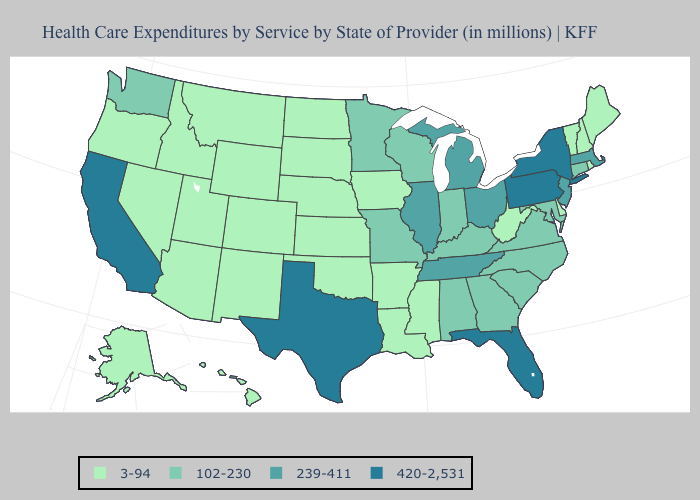Does the first symbol in the legend represent the smallest category?
Short answer required. Yes. Name the states that have a value in the range 239-411?
Keep it brief. Illinois, Massachusetts, Michigan, New Jersey, Ohio, Tennessee. Name the states that have a value in the range 420-2,531?
Quick response, please. California, Florida, New York, Pennsylvania, Texas. Which states have the lowest value in the USA?
Concise answer only. Alaska, Arizona, Arkansas, Colorado, Delaware, Hawaii, Idaho, Iowa, Kansas, Louisiana, Maine, Mississippi, Montana, Nebraska, Nevada, New Hampshire, New Mexico, North Dakota, Oklahoma, Oregon, Rhode Island, South Dakota, Utah, Vermont, West Virginia, Wyoming. Does Wyoming have the highest value in the USA?
Short answer required. No. Does Minnesota have the highest value in the USA?
Write a very short answer. No. Is the legend a continuous bar?
Quick response, please. No. Name the states that have a value in the range 102-230?
Write a very short answer. Alabama, Connecticut, Georgia, Indiana, Kentucky, Maryland, Minnesota, Missouri, North Carolina, South Carolina, Virginia, Washington, Wisconsin. What is the value of Nebraska?
Quick response, please. 3-94. Does North Dakota have a lower value than Hawaii?
Write a very short answer. No. Which states have the lowest value in the West?
Give a very brief answer. Alaska, Arizona, Colorado, Hawaii, Idaho, Montana, Nevada, New Mexico, Oregon, Utah, Wyoming. Which states have the highest value in the USA?
Write a very short answer. California, Florida, New York, Pennsylvania, Texas. What is the value of Pennsylvania?
Keep it brief. 420-2,531. Name the states that have a value in the range 3-94?
Be succinct. Alaska, Arizona, Arkansas, Colorado, Delaware, Hawaii, Idaho, Iowa, Kansas, Louisiana, Maine, Mississippi, Montana, Nebraska, Nevada, New Hampshire, New Mexico, North Dakota, Oklahoma, Oregon, Rhode Island, South Dakota, Utah, Vermont, West Virginia, Wyoming. 